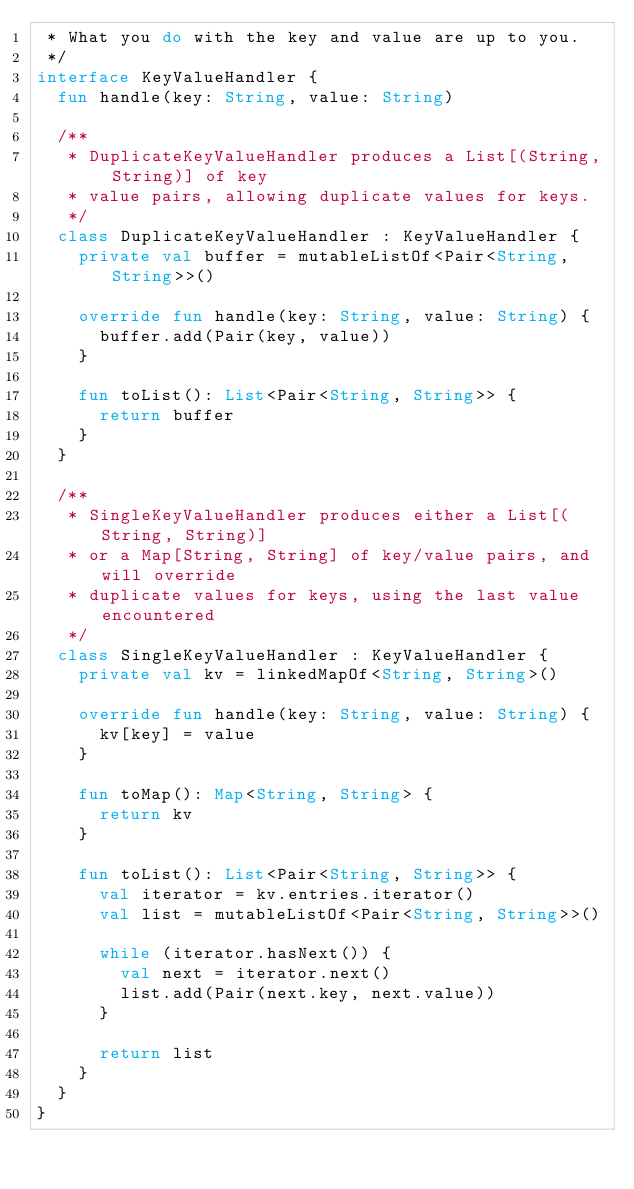Convert code to text. <code><loc_0><loc_0><loc_500><loc_500><_Kotlin_> * What you do with the key and value are up to you.
 */
interface KeyValueHandler {
  fun handle(key: String, value: String)

  /**
   * DuplicateKeyValueHandler produces a List[(String, String)] of key
   * value pairs, allowing duplicate values for keys.
   */
  class DuplicateKeyValueHandler : KeyValueHandler {
    private val buffer = mutableListOf<Pair<String, String>>()

    override fun handle(key: String, value: String) {
      buffer.add(Pair(key, value))
    }

    fun toList(): List<Pair<String, String>> {
      return buffer
    }
  }

  /**
   * SingleKeyValueHandler produces either a List[(String, String)]
   * or a Map[String, String] of key/value pairs, and will override
   * duplicate values for keys, using the last value encountered
   */
  class SingleKeyValueHandler : KeyValueHandler {
    private val kv = linkedMapOf<String, String>()

    override fun handle(key: String, value: String) {
      kv[key] = value
    }

    fun toMap(): Map<String, String> {
      return kv
    }

    fun toList(): List<Pair<String, String>> {
      val iterator = kv.entries.iterator()
      val list = mutableListOf<Pair<String, String>>()

      while (iterator.hasNext()) {
        val next = iterator.next()
        list.add(Pair(next.key, next.value))
      }

      return list
    }
  }
}
</code> 